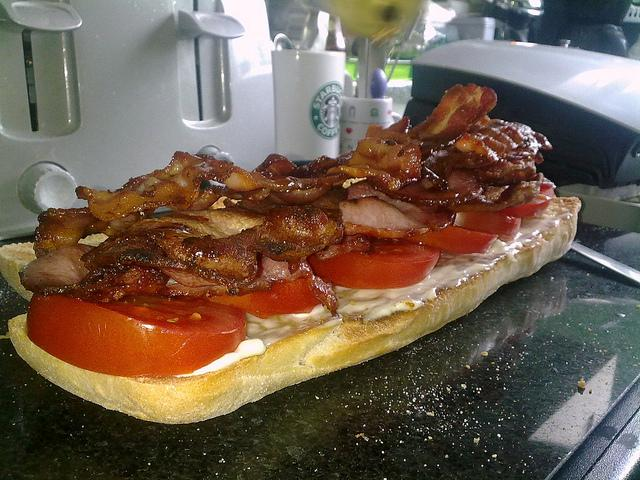What is missing to make a classic sandwich? lettuce 